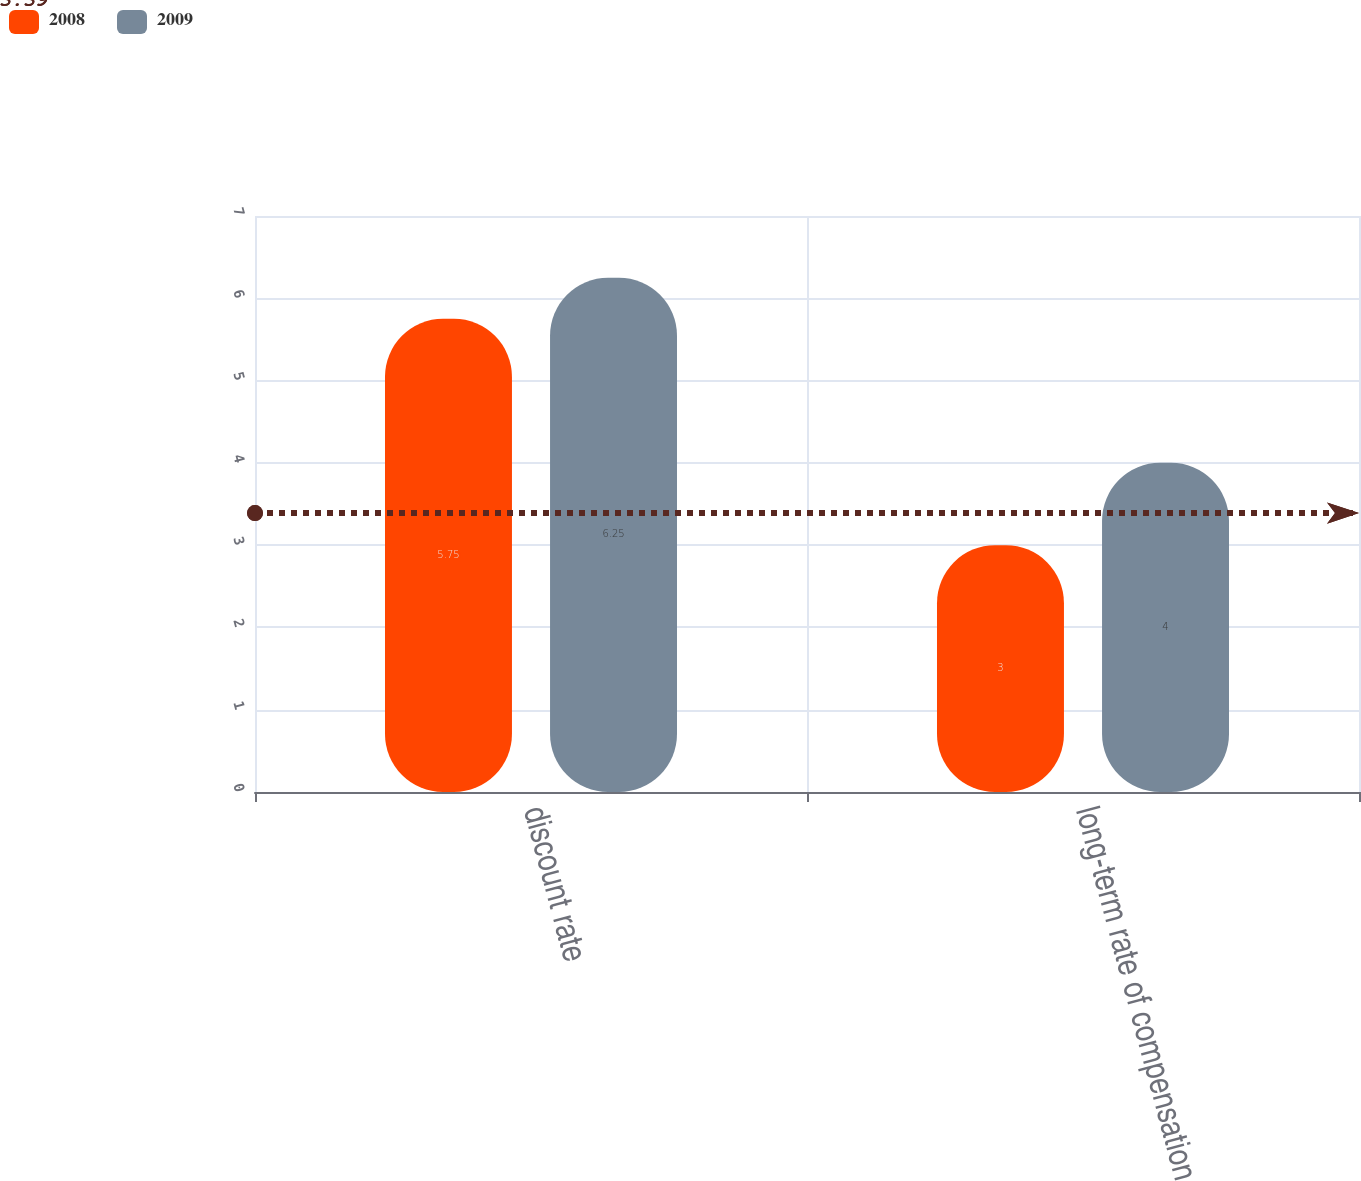Convert chart to OTSL. <chart><loc_0><loc_0><loc_500><loc_500><stacked_bar_chart><ecel><fcel>discount rate<fcel>long-term rate of compensation<nl><fcel>2008<fcel>5.75<fcel>3<nl><fcel>2009<fcel>6.25<fcel>4<nl></chart> 